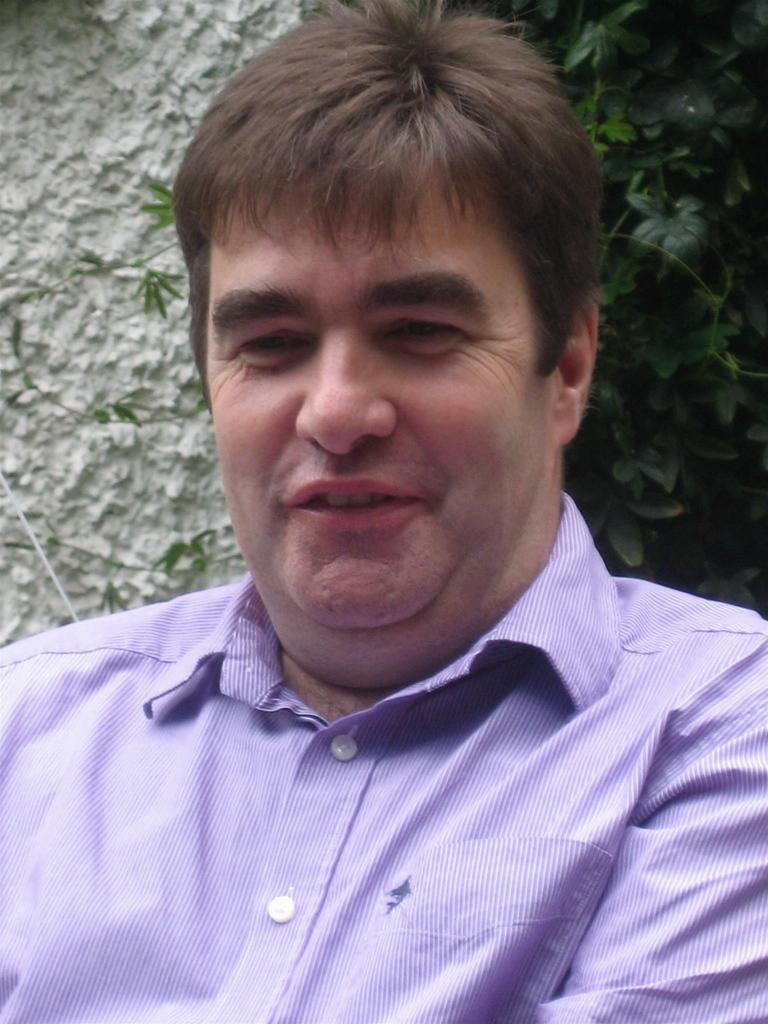Who or what is present in the image? There is a person in the image. What can be seen in the distance behind the person? There are trees and a wall in the background of the image. What type of branch is the person using to aid their digestion in the image? There is no branch or mention of digestion in the image; it simply features a person and a background with trees and a wall. 